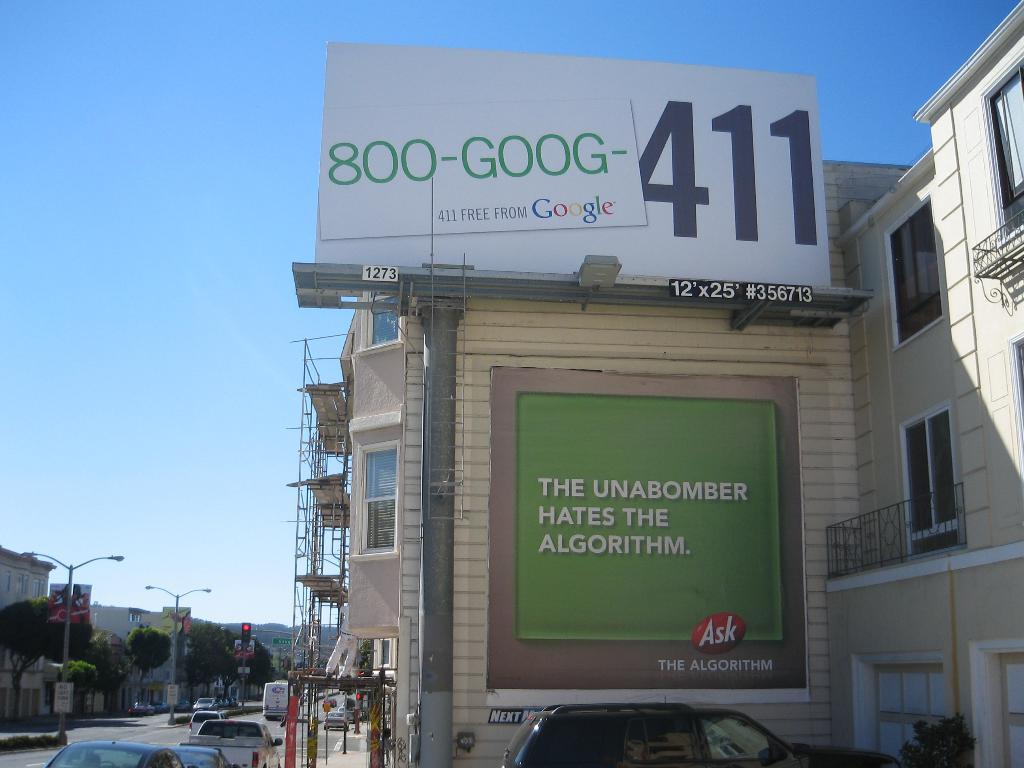<image>
Share a concise interpretation of the image provided. A building outside has a billboard on top of it, advertising Google services. 